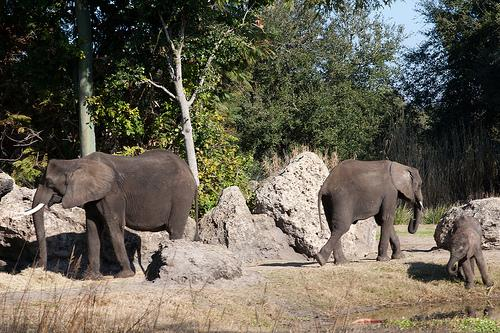Describe the scene at the zoo in the image. At the zoo, three elephants, including a baby, are standing near green grass, trees, dead grass, and rocks. There's a large rock behind one of the elephants and a pool beside them. In the sky, you can even see something red floating in the water. Describe the main focus of the image and its surroundings using a journalistic style. Captured in a fleeting moment, this striking image features three elephants – a baby among them – as they roam the grounds of their zoo enclosure. Encircled by a vividly green expanse of grass, towering trees, and rugged rocks, the scene also reveals a serene pool by the elephants, hinting at a tranquil environment for the majestic creatures. List the main characteristics and details of the image in an objective manner. Gray elephants, green grass, trees, rocks, blue sky, zoo setting, baby elephant, yellow tree leaves, elephant body parts, dead grass, pool with red object in water. Explain the image as if you were describing it to someone who's never seen an elephant before. The image shows three large gray creatures with long curved ivory tusks, a long trunk, big ears, and thick legs. These are called elephants. They're standing on the ground surrounded by trees, grass, and rocks, with a blue sky above. One of the elephants is a baby, which is smaller and cuter. They are in a place called a zoo. Provide a brief overview of the image in a casual tone. Oh, it's a lovely picture of elephants hanging out at the zoo! There's a baby elephant too, and some trees and rocks around them. The grass is green, and there's even a pool nearby! Explain the main components of the image in a dramatic tone. In a world of gray giants, nobly standing tall by vibrant green grass and mesmerizing trees, there comes forth a baby elephant seeking warmth from its mighty family. Behold! Rocks and water bring breathtaking contrast, while resplendent tree leaves drape the scene in a golden hue! Write a short and simple description of the image for children. This is a picture of a mommy elephant, a daddy elephant, and a baby elephant at the zoo. They are near green grass, trees, and a pool of water. There are also some rocks and leaves in the picture. Provide a poetic description of the image. In this serene and tranquil place. Write a description of the image as if it were a scene from a novel. Under the vast blue sky of the sunlit zoo, three elephants roamed peacefully in their enclosure, meandering among lush grass and the comforting shade of towering trees. A gentle hush fell over the scene, interrupted only by the distant murmur of water from a nearby pool. The smallest elephant, barely older than a calf, trotted close to its parents, the wonder of the world reflected in its innocent eyes. Summarize the main elements of the image in a formal style. The image depicts three elephants – an adult male, an adult female, and a juvenile – in a zoological setting, surrounded by verdant grass and foliage, as well as various geological features such as rocks and a pool of water. The sky is blue, and certain tree leaves exhibit a yellow hue. 